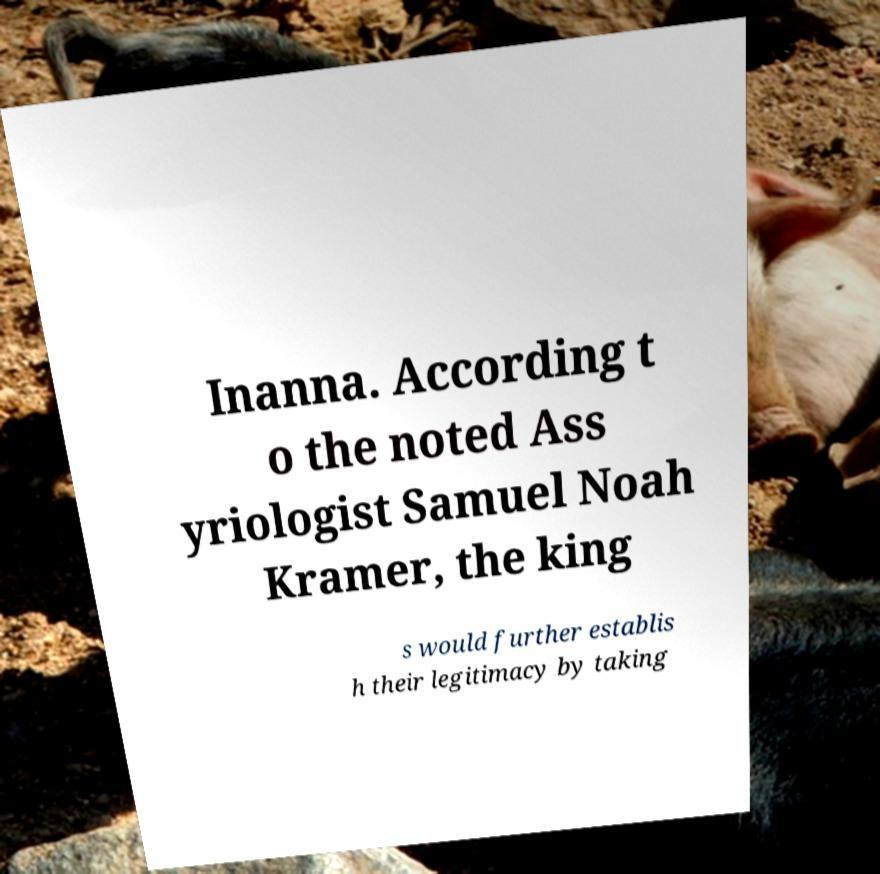Could you assist in decoding the text presented in this image and type it out clearly? Inanna. According t o the noted Ass yriologist Samuel Noah Kramer, the king s would further establis h their legitimacy by taking 